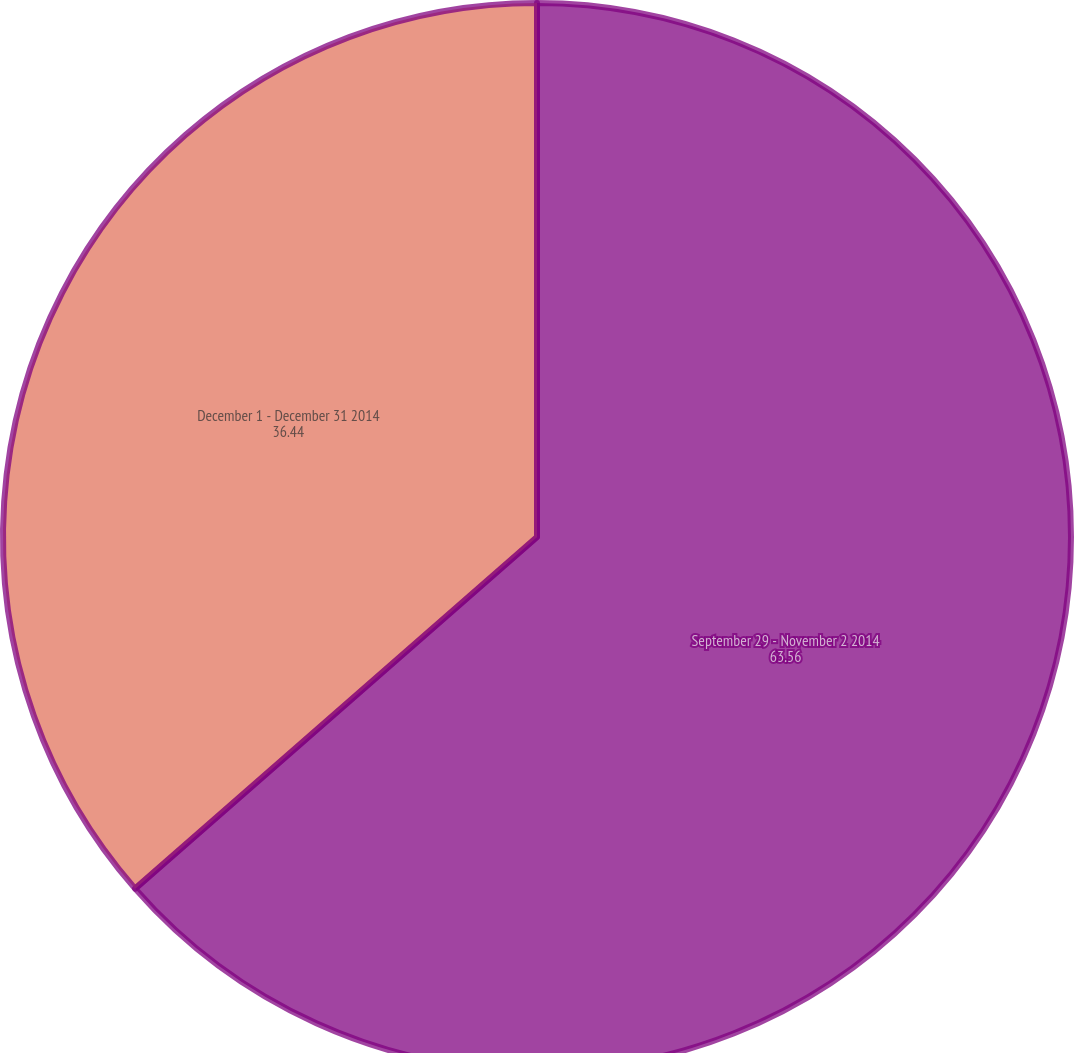Convert chart to OTSL. <chart><loc_0><loc_0><loc_500><loc_500><pie_chart><fcel>September 29 - November 2 2014<fcel>December 1 - December 31 2014<nl><fcel>63.56%<fcel>36.44%<nl></chart> 